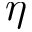Convert formula to latex. <formula><loc_0><loc_0><loc_500><loc_500>\eta</formula> 